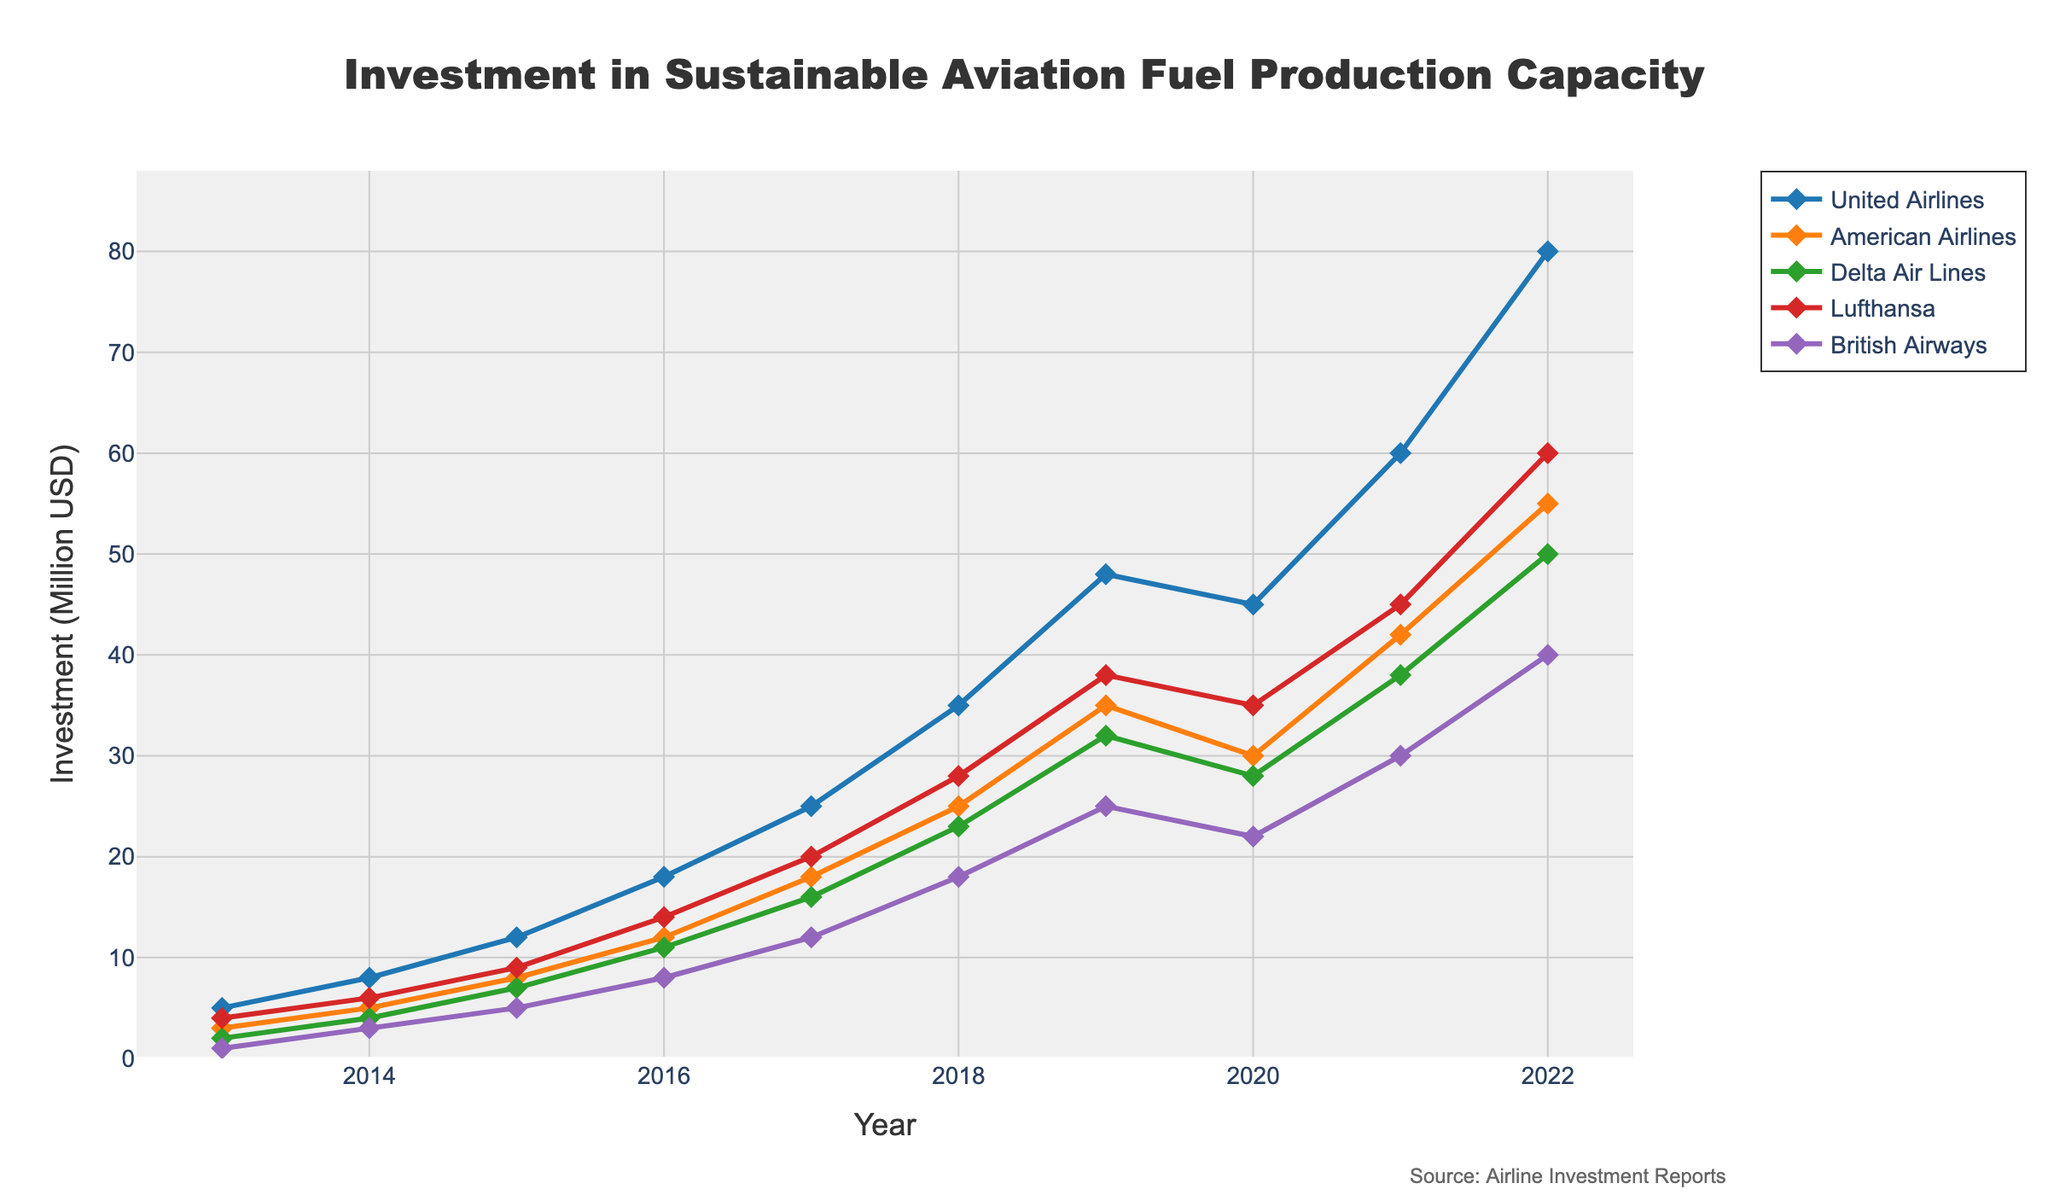What is the trend in United Airlines’ investment in sustainable aviation fuel production from 2013 to 2022? The plot shows an increasing trend in United Airlines' investment over the years, starting at 5 million USD in 2013 and rising to 80 million USD by 2022, with some fluctuations around 2019 and 2020.
Answer: Increasing trend Which airline had the highest investment in 2019? In 2019, United Airlines had the highest investment among all the airlines, with 48 million USD. This can be seen by identifying the highest line marker on the chart for that year.
Answer: United Airlines What is the total investment made by Delta Air Lines from 2013 to 2022? Sum Delta Air Lines’ investment values from the chart: 2 + 4 + 7 + 11 + 16 + 23 + 32 + 28 + 38 + 50 = 211 million USD.
Answer: 211 million USD Compare the investment growth rates between British Airways and Lufthansa from 2013 to 2022. British Airways increased its investment from 1 million to 40 million USD, a 39 million increase. Lufthansa went from 4 million to 60 million USD, a 56 million increase. Thus, Lufthansa had a higher growth rate.
Answer: Lufthansa had a higher growth rate Which year did American Airlines have the lowest investment in sustainable aviation fuel production? By inspecting the American Airlines line on the plot, the lowest investment was in 2013 with 3 million USD.
Answer: 2013 What is the percentage increase in United Airlines’ investment from 2013 to 2022? United Airlines’ investment increased from 5 million to 80 million USD. Percentage increase = [(80 - 5) / 5] * 100% = 1500%.
Answer: 1500% Between 2015 and 2020, which airline had the smallest absolute increase in investment? Calculate the differences: United Airlines: 45-12=33, American Airlines: 30-8=22, Delta Air Lines: 28-7=21, Lufthansa: 35-9=26, British Airways: 22-5=17. British Airways had the smallest increase of 17 million USD.
Answer: British Airways Which airline's investment showed a decline between any two consecutive years? United Airlines' investment decreased from 48 million USD in 2019 to 45 million USD in 2020. This decline is visible as a drop in the line graph.
Answer: United Airlines What is the average investment by all airlines in 2017? Calculate the average of investments: (25 + 18 + 16 + 20 + 12) / 5 = 91 / 5 = 18.2 million USD.
Answer: 18.2 million USD 